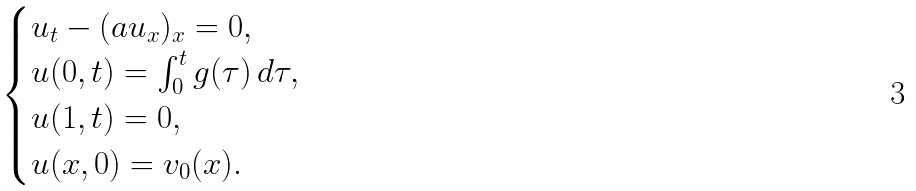Convert formula to latex. <formula><loc_0><loc_0><loc_500><loc_500>\begin{cases} u _ { t } - ( a u _ { x } ) _ { x } = 0 , \\ u ( 0 , t ) = \int _ { 0 } ^ { t } g ( \tau ) \, d \tau , \\ u ( 1 , t ) = 0 , \\ u ( x , 0 ) = v _ { 0 } ( x ) . \end{cases}</formula> 